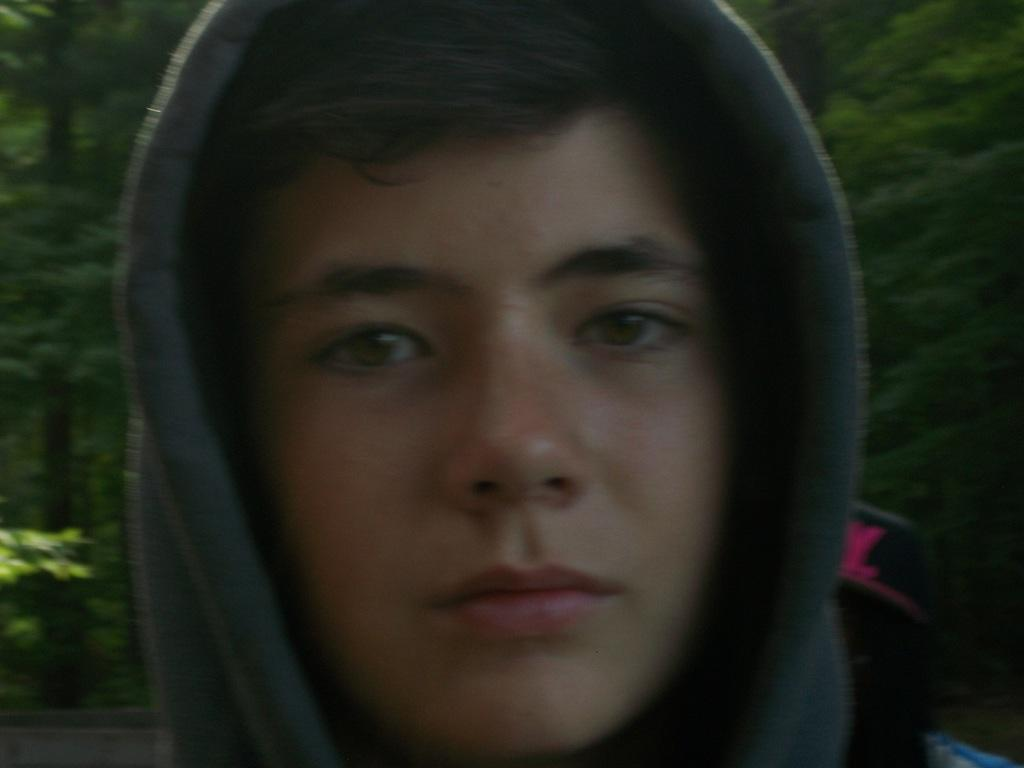What is the main subject of the image? There is a person standing in the image. What is the person wearing? The person is wearing a hoodie. What can be seen in the background of the image? There are trees and plants in the backdrop of the image. What arithmetic problem is the person solving in the image? There is no arithmetic problem visible in the image; the person is simply standing. How does the person stretch in the image? A: The person is not stretching in the image; they are standing still. 